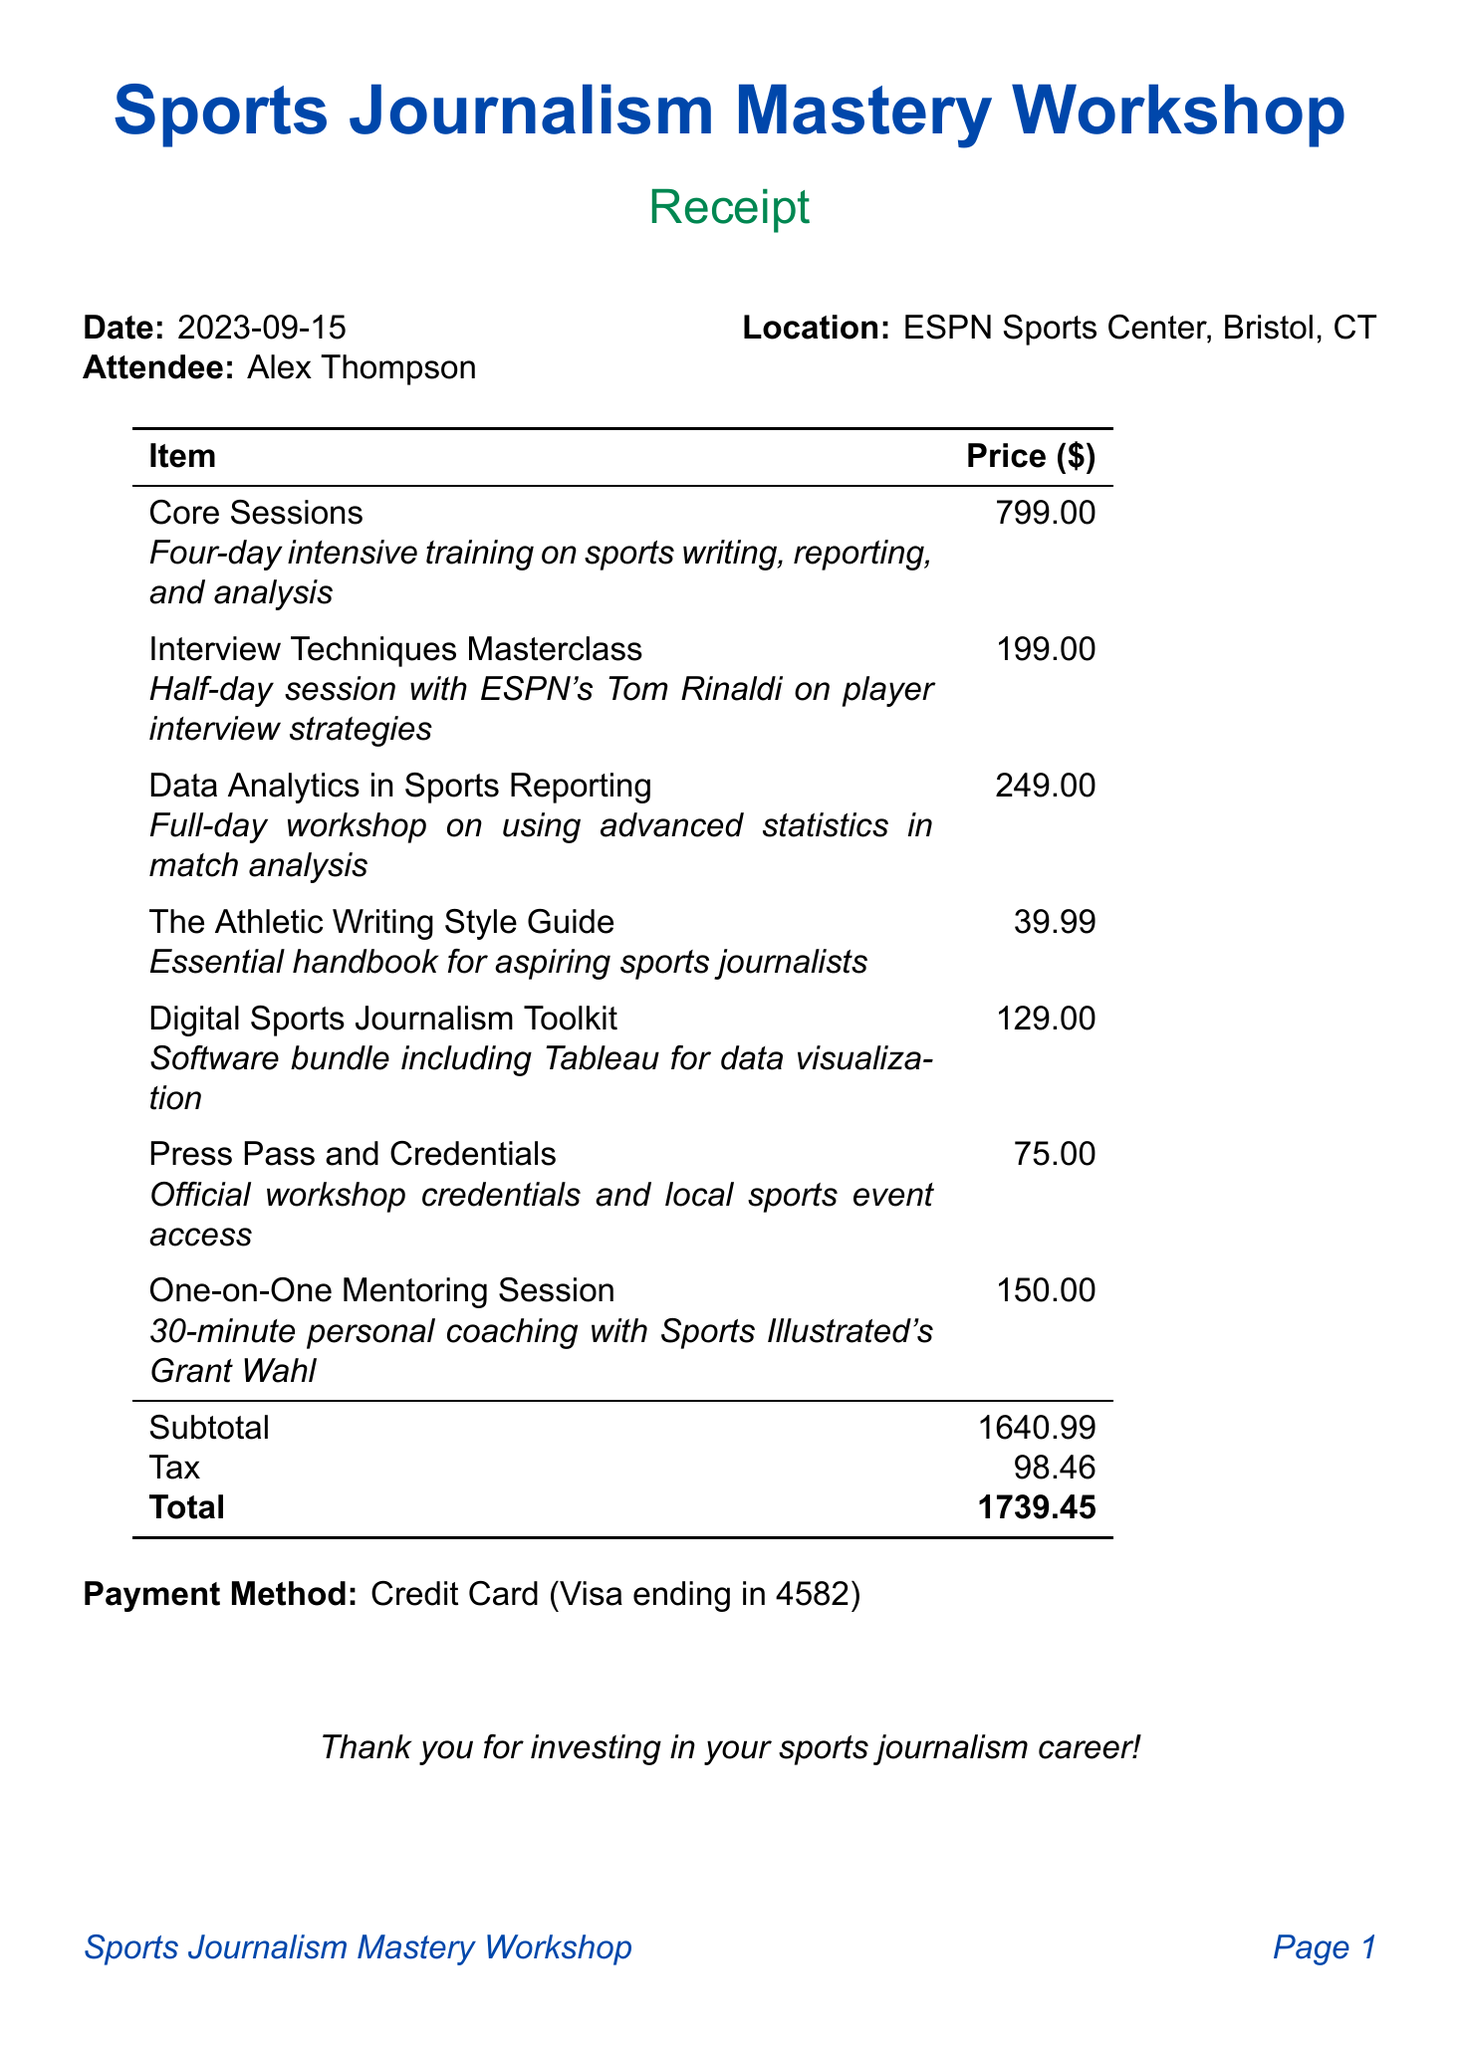what is the workshop name? The workshop name is presented at the top of the document, clearly stating the title.
Answer: Sports Journalism Mastery Workshop what is the date of the workshop? The date is mentioned in the header section of the receipt, indicating when the workshop took place.
Answer: 2023-09-15 who is the attendee? The attendee's name is specified in the document, indicating who participated in the workshop.
Answer: Alex Thompson what is the price of the Core Sessions? The price for Core Sessions is listed in the itemized charges in the document under the respective section.
Answer: 799.00 what is the total amount paid? The total amount is calculated and presented at the bottom of the receipt, summarizing the final payment.
Answer: 1739.45 how much was spent on taxes? The tax amount is specified in the breakdown of costs in the document.
Answer: 98.46 which session cost the least? By reviewing the itemized list, the cost for each session is compared to find the lowest one.
Answer: The Athletic Writing Style Guide how many total items were charged? The total items listed can be counted in the itemized section of the document.
Answer: 7 what is the payment method used? The payment method is described at the end of the receipt, indicating how the payment was made.
Answer: Credit Card (Visa ending in 4582) 